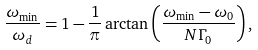Convert formula to latex. <formula><loc_0><loc_0><loc_500><loc_500>\frac { \omega _ { \min } } { \omega _ { d } } = 1 - \frac { 1 } { \pi } \arctan \left ( \frac { \omega _ { \min } - \omega _ { 0 } } { N \Gamma _ { 0 } } \right ) ,</formula> 